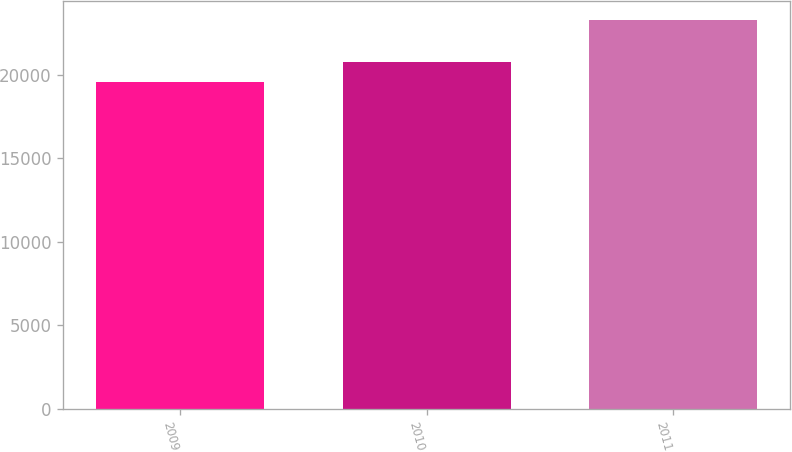Convert chart to OTSL. <chart><loc_0><loc_0><loc_500><loc_500><bar_chart><fcel>2009<fcel>2010<fcel>2011<nl><fcel>19595<fcel>20747<fcel>23277<nl></chart> 